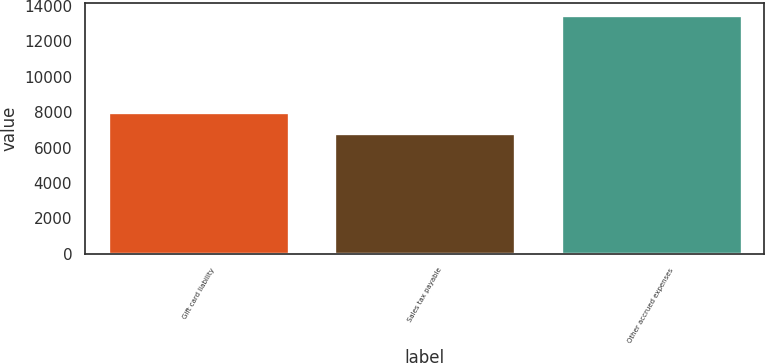Convert chart. <chart><loc_0><loc_0><loc_500><loc_500><bar_chart><fcel>Gift card liability<fcel>Sales tax payable<fcel>Other accrued expenses<nl><fcel>8013<fcel>6842<fcel>13492<nl></chart> 